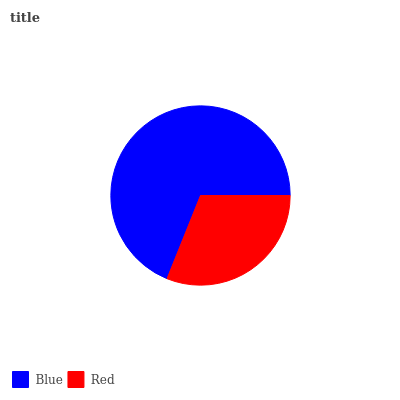Is Red the minimum?
Answer yes or no. Yes. Is Blue the maximum?
Answer yes or no. Yes. Is Red the maximum?
Answer yes or no. No. Is Blue greater than Red?
Answer yes or no. Yes. Is Red less than Blue?
Answer yes or no. Yes. Is Red greater than Blue?
Answer yes or no. No. Is Blue less than Red?
Answer yes or no. No. Is Blue the high median?
Answer yes or no. Yes. Is Red the low median?
Answer yes or no. Yes. Is Red the high median?
Answer yes or no. No. Is Blue the low median?
Answer yes or no. No. 